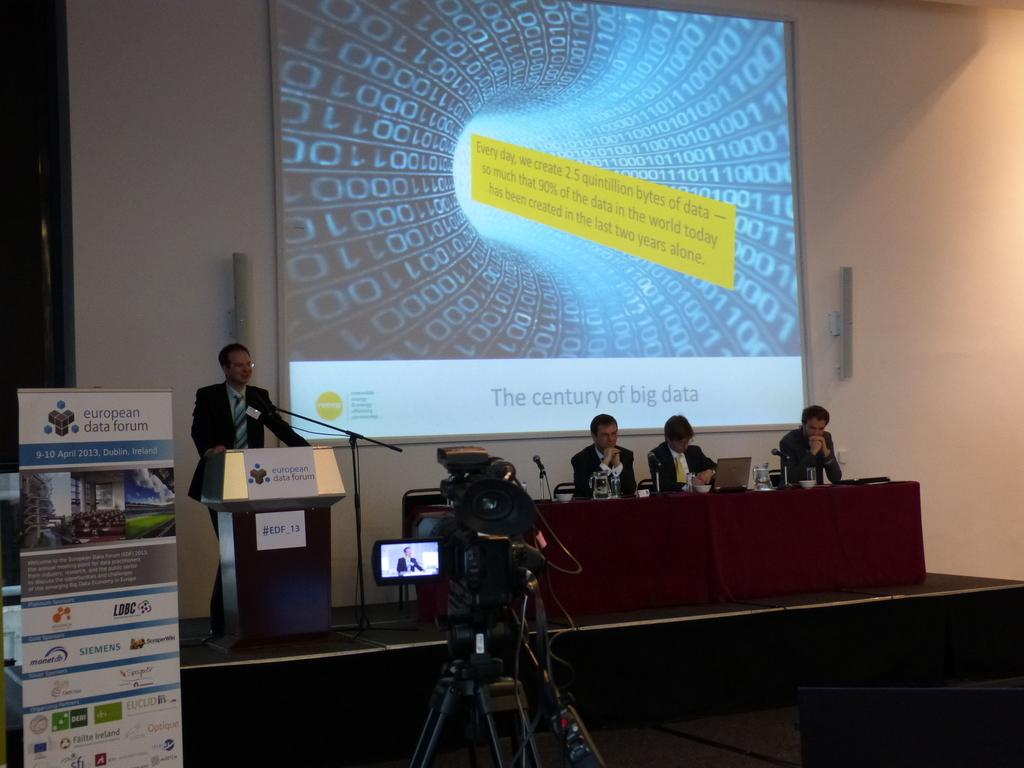Provide a one-sentence caption for the provided image. man giving lecture on stage at european data forum in dublin, ireland. 